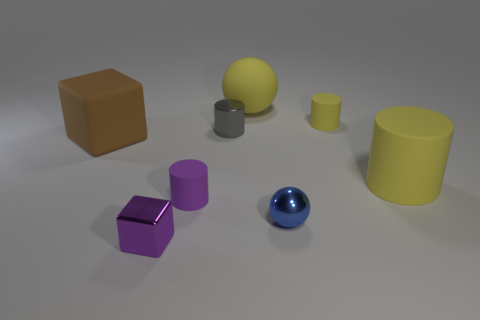What color is the tiny matte cylinder right of the ball in front of the matte block?
Provide a short and direct response. Yellow. Are there fewer blue things than tiny blue cubes?
Your answer should be very brief. No. What number of other blue shiny objects have the same shape as the small blue thing?
Your response must be concise. 0. There is another metal cylinder that is the same size as the purple cylinder; what is its color?
Ensure brevity in your answer.  Gray. Is the number of small rubber things on the left side of the small metallic cube the same as the number of tiny gray things that are in front of the brown rubber thing?
Provide a short and direct response. Yes. Is there a gray metal object of the same size as the yellow ball?
Give a very brief answer. No. How big is the gray shiny object?
Your response must be concise. Small. Is the number of tiny gray metal objects that are in front of the blue metallic ball the same as the number of tiny red metallic balls?
Offer a terse response. Yes. What number of other things are the same color as the big rubber block?
Give a very brief answer. 0. There is a metal object that is in front of the big cylinder and behind the tiny purple cube; what is its color?
Offer a terse response. Blue. 